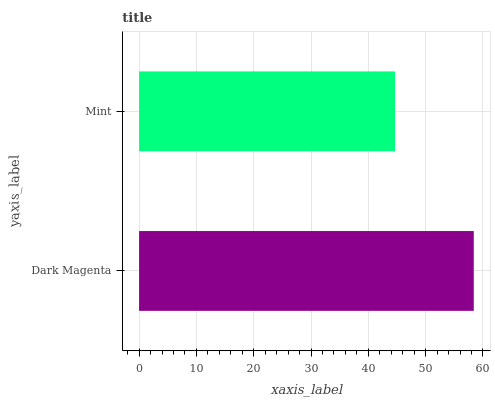Is Mint the minimum?
Answer yes or no. Yes. Is Dark Magenta the maximum?
Answer yes or no. Yes. Is Mint the maximum?
Answer yes or no. No. Is Dark Magenta greater than Mint?
Answer yes or no. Yes. Is Mint less than Dark Magenta?
Answer yes or no. Yes. Is Mint greater than Dark Magenta?
Answer yes or no. No. Is Dark Magenta less than Mint?
Answer yes or no. No. Is Dark Magenta the high median?
Answer yes or no. Yes. Is Mint the low median?
Answer yes or no. Yes. Is Mint the high median?
Answer yes or no. No. Is Dark Magenta the low median?
Answer yes or no. No. 